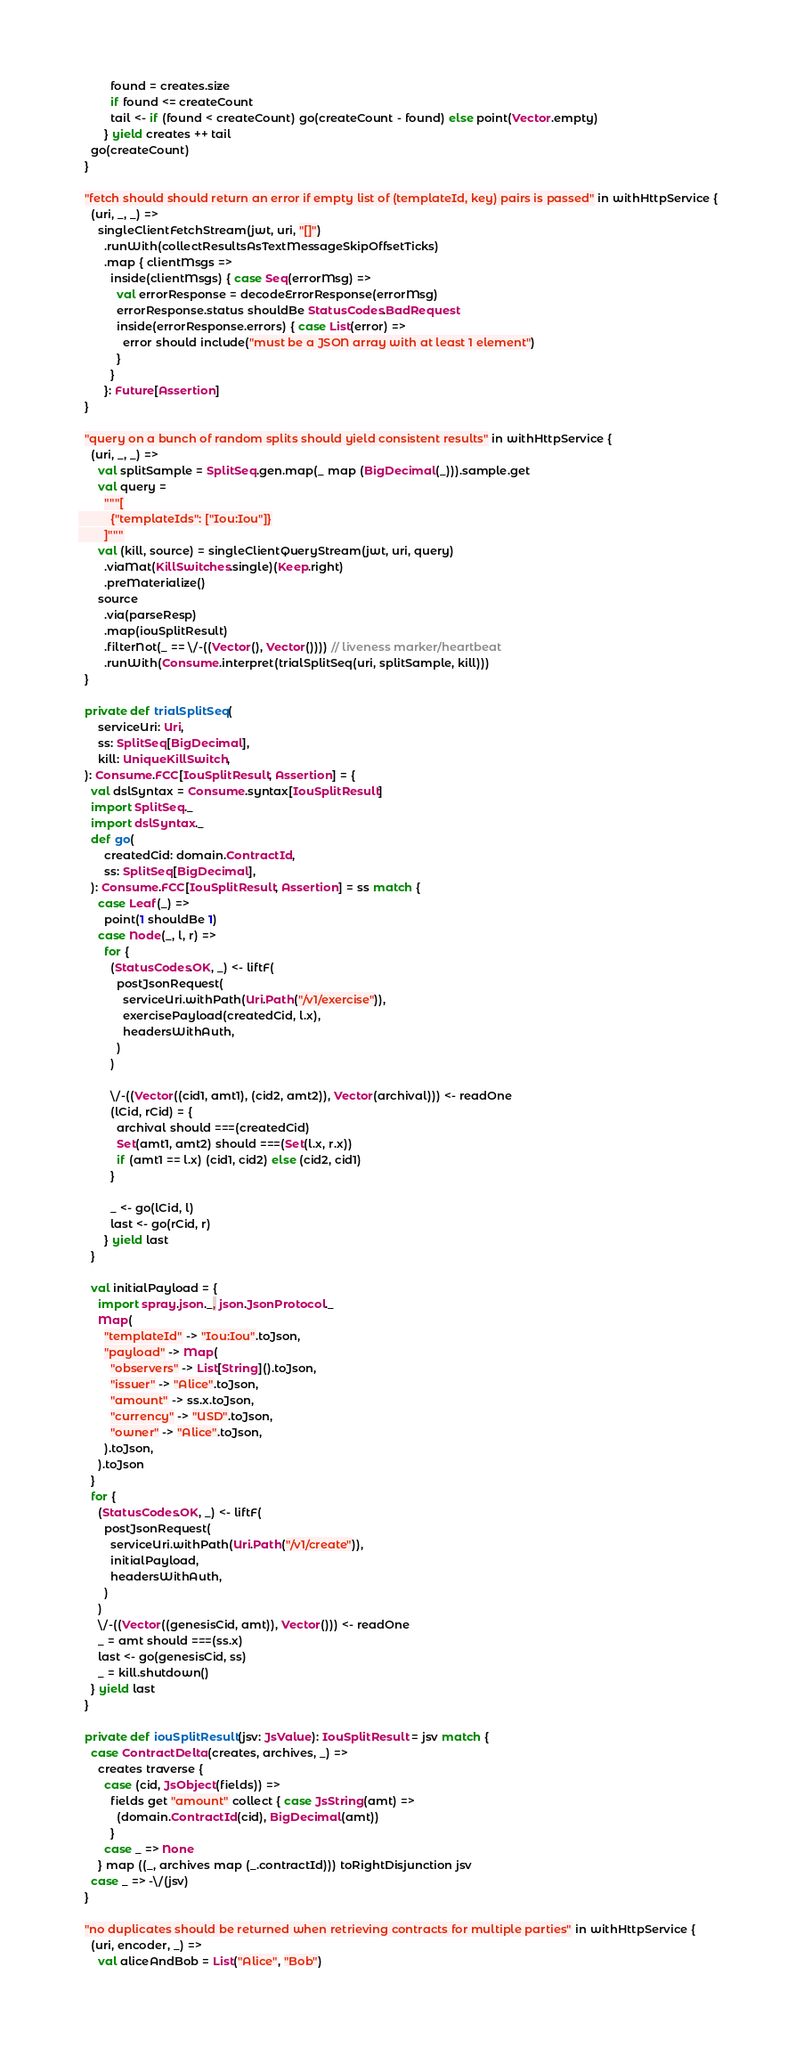<code> <loc_0><loc_0><loc_500><loc_500><_Scala_>          found = creates.size
          if found <= createCount
          tail <- if (found < createCount) go(createCount - found) else point(Vector.empty)
        } yield creates ++ tail
    go(createCount)
  }

  "fetch should should return an error if empty list of (templateId, key) pairs is passed" in withHttpService {
    (uri, _, _) =>
      singleClientFetchStream(jwt, uri, "[]")
        .runWith(collectResultsAsTextMessageSkipOffsetTicks)
        .map { clientMsgs =>
          inside(clientMsgs) { case Seq(errorMsg) =>
            val errorResponse = decodeErrorResponse(errorMsg)
            errorResponse.status shouldBe StatusCodes.BadRequest
            inside(errorResponse.errors) { case List(error) =>
              error should include("must be a JSON array with at least 1 element")
            }
          }
        }: Future[Assertion]
  }

  "query on a bunch of random splits should yield consistent results" in withHttpService {
    (uri, _, _) =>
      val splitSample = SplitSeq.gen.map(_ map (BigDecimal(_))).sample.get
      val query =
        """[
          {"templateIds": ["Iou:Iou"]}
        ]"""
      val (kill, source) = singleClientQueryStream(jwt, uri, query)
        .viaMat(KillSwitches.single)(Keep.right)
        .preMaterialize()
      source
        .via(parseResp)
        .map(iouSplitResult)
        .filterNot(_ == \/-((Vector(), Vector()))) // liveness marker/heartbeat
        .runWith(Consume.interpret(trialSplitSeq(uri, splitSample, kill)))
  }

  private def trialSplitSeq(
      serviceUri: Uri,
      ss: SplitSeq[BigDecimal],
      kill: UniqueKillSwitch,
  ): Consume.FCC[IouSplitResult, Assertion] = {
    val dslSyntax = Consume.syntax[IouSplitResult]
    import SplitSeq._
    import dslSyntax._
    def go(
        createdCid: domain.ContractId,
        ss: SplitSeq[BigDecimal],
    ): Consume.FCC[IouSplitResult, Assertion] = ss match {
      case Leaf(_) =>
        point(1 shouldBe 1)
      case Node(_, l, r) =>
        for {
          (StatusCodes.OK, _) <- liftF(
            postJsonRequest(
              serviceUri.withPath(Uri.Path("/v1/exercise")),
              exercisePayload(createdCid, l.x),
              headersWithAuth,
            )
          )

          \/-((Vector((cid1, amt1), (cid2, amt2)), Vector(archival))) <- readOne
          (lCid, rCid) = {
            archival should ===(createdCid)
            Set(amt1, amt2) should ===(Set(l.x, r.x))
            if (amt1 == l.x) (cid1, cid2) else (cid2, cid1)
          }

          _ <- go(lCid, l)
          last <- go(rCid, r)
        } yield last
    }

    val initialPayload = {
      import spray.json._, json.JsonProtocol._
      Map(
        "templateId" -> "Iou:Iou".toJson,
        "payload" -> Map(
          "observers" -> List[String]().toJson,
          "issuer" -> "Alice".toJson,
          "amount" -> ss.x.toJson,
          "currency" -> "USD".toJson,
          "owner" -> "Alice".toJson,
        ).toJson,
      ).toJson
    }
    for {
      (StatusCodes.OK, _) <- liftF(
        postJsonRequest(
          serviceUri.withPath(Uri.Path("/v1/create")),
          initialPayload,
          headersWithAuth,
        )
      )
      \/-((Vector((genesisCid, amt)), Vector())) <- readOne
      _ = amt should ===(ss.x)
      last <- go(genesisCid, ss)
      _ = kill.shutdown()
    } yield last
  }

  private def iouSplitResult(jsv: JsValue): IouSplitResult = jsv match {
    case ContractDelta(creates, archives, _) =>
      creates traverse {
        case (cid, JsObject(fields)) =>
          fields get "amount" collect { case JsString(amt) =>
            (domain.ContractId(cid), BigDecimal(amt))
          }
        case _ => None
      } map ((_, archives map (_.contractId))) toRightDisjunction jsv
    case _ => -\/(jsv)
  }

  "no duplicates should be returned when retrieving contracts for multiple parties" in withHttpService {
    (uri, encoder, _) =>
      val aliceAndBob = List("Alice", "Bob")</code> 